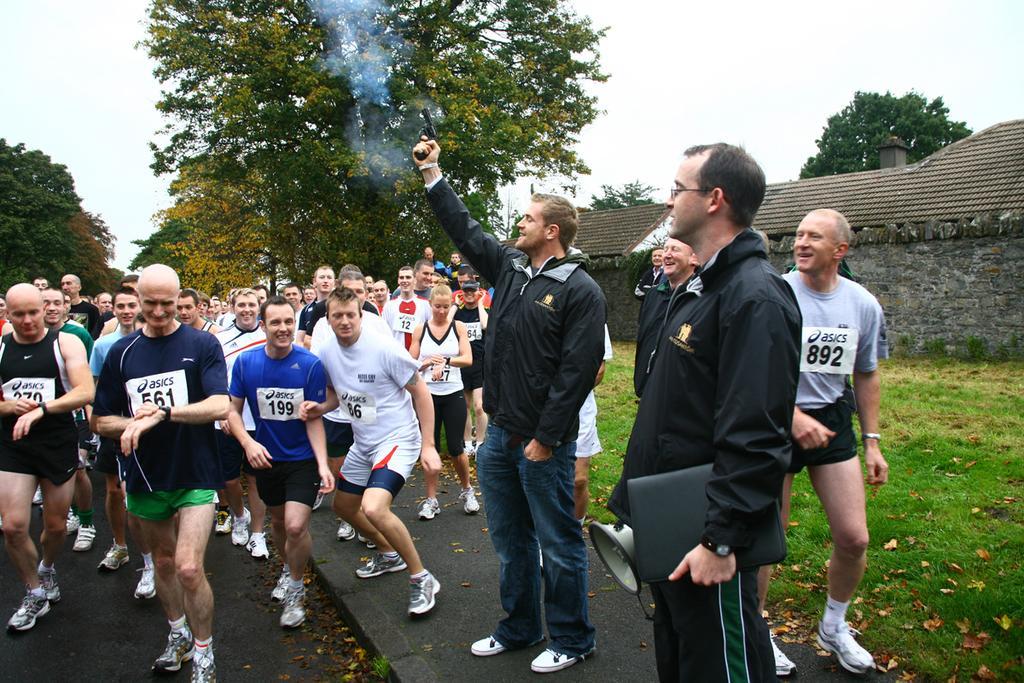Describe this image in one or two sentences. In this image in front there are people. On the right side of the image there is grass on the surface. In the background there are trees, buildings and sky. At the bottom of the image there is a road. 